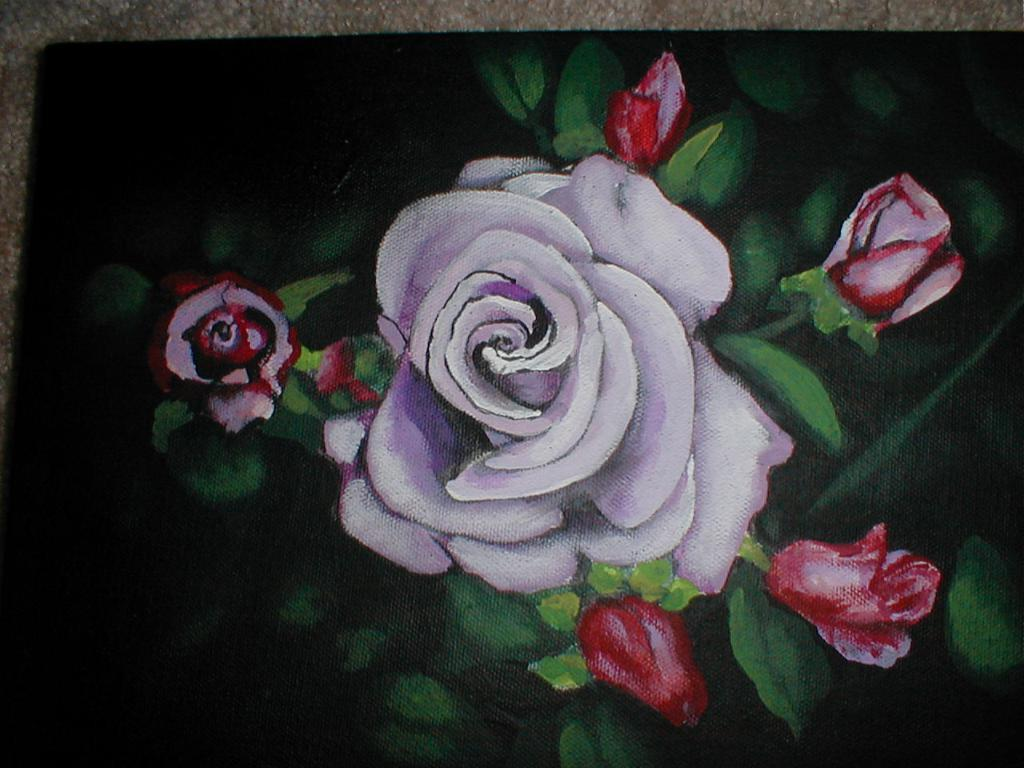What is the main subject of the image? There is a painting in the image. What is depicted in the painting? The painting depicts rose flowers. What type of mark can be seen on the painting in the image? There is no mention of any mark on the painting in the provided facts, so we cannot answer this question. 